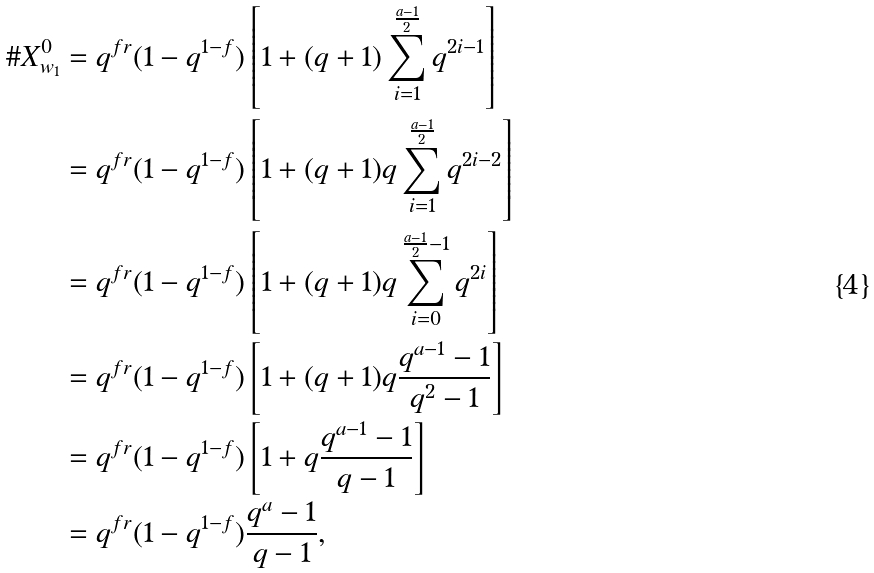<formula> <loc_0><loc_0><loc_500><loc_500>\# X ^ { 0 } _ { w _ { 1 } } & = q ^ { f r } ( 1 - q ^ { 1 - f } ) \left [ 1 + ( q + 1 ) \sum _ { i = 1 } ^ { \frac { a - 1 } { 2 } } q ^ { 2 i - 1 } \right ] \\ & = q ^ { f r } ( 1 - q ^ { 1 - f } ) \left [ 1 + ( q + 1 ) q \sum _ { i = 1 } ^ { \frac { a - 1 } { 2 } } q ^ { 2 i - 2 } \right ] \\ & = q ^ { f r } ( 1 - q ^ { 1 - f } ) \left [ 1 + ( q + 1 ) q \sum _ { i = 0 } ^ { \frac { a - 1 } { 2 } - 1 } q ^ { 2 i } \right ] \\ & = q ^ { f r } ( 1 - q ^ { 1 - f } ) \left [ 1 + ( q + 1 ) q \frac { q ^ { a - 1 } - 1 } { q ^ { 2 } - 1 } \right ] \\ & = q ^ { f r } ( 1 - q ^ { 1 - f } ) \left [ 1 + q \frac { q ^ { a - 1 } - 1 } { q - 1 } \right ] \\ & = q ^ { f r } ( 1 - q ^ { 1 - f } ) \frac { q ^ { a } - 1 } { q - 1 } ,</formula> 